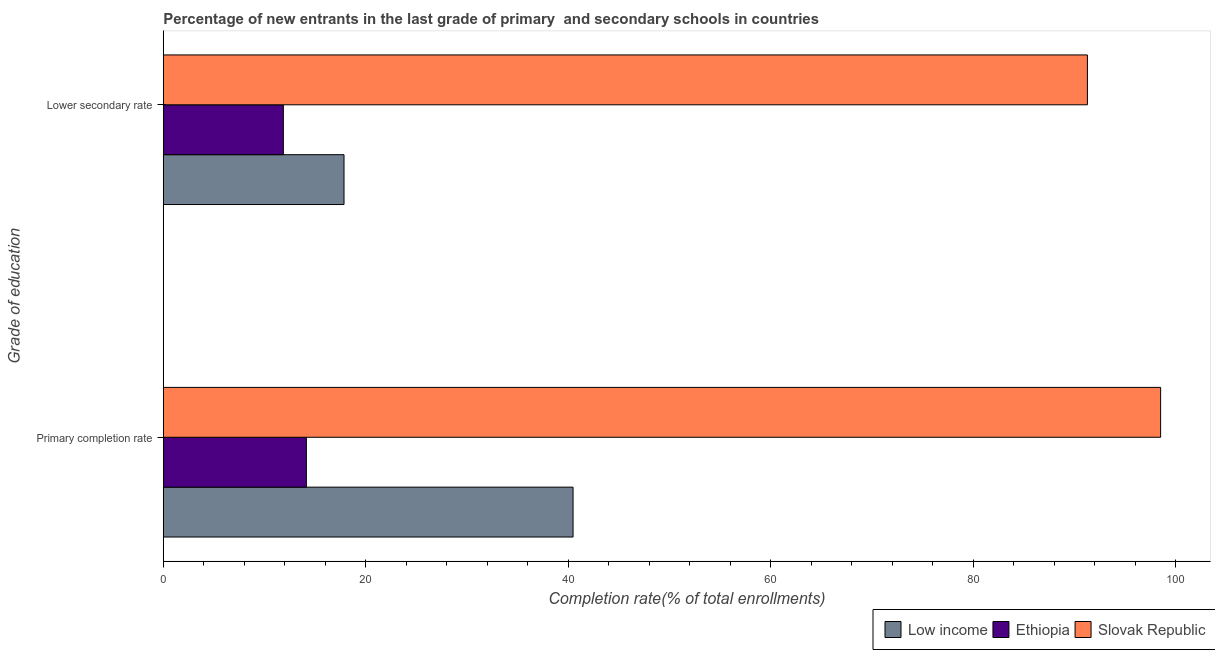How many groups of bars are there?
Make the answer very short. 2. Are the number of bars on each tick of the Y-axis equal?
Your answer should be compact. Yes. How many bars are there on the 2nd tick from the top?
Ensure brevity in your answer.  3. What is the label of the 2nd group of bars from the top?
Offer a very short reply. Primary completion rate. What is the completion rate in secondary schools in Ethiopia?
Ensure brevity in your answer.  11.86. Across all countries, what is the maximum completion rate in primary schools?
Ensure brevity in your answer.  98.52. Across all countries, what is the minimum completion rate in primary schools?
Make the answer very short. 14.14. In which country was the completion rate in secondary schools maximum?
Make the answer very short. Slovak Republic. In which country was the completion rate in primary schools minimum?
Your response must be concise. Ethiopia. What is the total completion rate in primary schools in the graph?
Make the answer very short. 153.14. What is the difference between the completion rate in primary schools in Low income and that in Slovak Republic?
Your answer should be compact. -58.04. What is the difference between the completion rate in primary schools in Slovak Republic and the completion rate in secondary schools in Ethiopia?
Your response must be concise. 86.66. What is the average completion rate in secondary schools per country?
Your answer should be very brief. 40.34. What is the difference between the completion rate in secondary schools and completion rate in primary schools in Low income?
Provide a succinct answer. -22.63. In how many countries, is the completion rate in primary schools greater than 92 %?
Your answer should be very brief. 1. What is the ratio of the completion rate in primary schools in Ethiopia to that in Slovak Republic?
Your answer should be very brief. 0.14. Is the completion rate in secondary schools in Low income less than that in Slovak Republic?
Make the answer very short. Yes. What does the 2nd bar from the top in Primary completion rate represents?
Ensure brevity in your answer.  Ethiopia. What does the 3rd bar from the bottom in Lower secondary rate represents?
Keep it short and to the point. Slovak Republic. How many bars are there?
Your response must be concise. 6. Are all the bars in the graph horizontal?
Offer a very short reply. Yes. What is the difference between two consecutive major ticks on the X-axis?
Your answer should be compact. 20. Does the graph contain any zero values?
Your answer should be compact. No. Does the graph contain grids?
Offer a very short reply. No. Where does the legend appear in the graph?
Provide a succinct answer. Bottom right. How many legend labels are there?
Ensure brevity in your answer.  3. How are the legend labels stacked?
Offer a terse response. Horizontal. What is the title of the graph?
Provide a succinct answer. Percentage of new entrants in the last grade of primary  and secondary schools in countries. Does "Togo" appear as one of the legend labels in the graph?
Ensure brevity in your answer.  No. What is the label or title of the X-axis?
Ensure brevity in your answer.  Completion rate(% of total enrollments). What is the label or title of the Y-axis?
Your answer should be compact. Grade of education. What is the Completion rate(% of total enrollments) of Low income in Primary completion rate?
Your answer should be compact. 40.48. What is the Completion rate(% of total enrollments) in Ethiopia in Primary completion rate?
Make the answer very short. 14.14. What is the Completion rate(% of total enrollments) in Slovak Republic in Primary completion rate?
Provide a short and direct response. 98.52. What is the Completion rate(% of total enrollments) of Low income in Lower secondary rate?
Your answer should be very brief. 17.86. What is the Completion rate(% of total enrollments) in Ethiopia in Lower secondary rate?
Your answer should be very brief. 11.86. What is the Completion rate(% of total enrollments) in Slovak Republic in Lower secondary rate?
Your answer should be very brief. 91.29. Across all Grade of education, what is the maximum Completion rate(% of total enrollments) of Low income?
Your response must be concise. 40.48. Across all Grade of education, what is the maximum Completion rate(% of total enrollments) of Ethiopia?
Your response must be concise. 14.14. Across all Grade of education, what is the maximum Completion rate(% of total enrollments) in Slovak Republic?
Provide a succinct answer. 98.52. Across all Grade of education, what is the minimum Completion rate(% of total enrollments) in Low income?
Your answer should be compact. 17.86. Across all Grade of education, what is the minimum Completion rate(% of total enrollments) of Ethiopia?
Keep it short and to the point. 11.86. Across all Grade of education, what is the minimum Completion rate(% of total enrollments) in Slovak Republic?
Your answer should be compact. 91.29. What is the total Completion rate(% of total enrollments) in Low income in the graph?
Provide a short and direct response. 58.34. What is the total Completion rate(% of total enrollments) in Ethiopia in the graph?
Ensure brevity in your answer.  26. What is the total Completion rate(% of total enrollments) in Slovak Republic in the graph?
Your answer should be compact. 189.82. What is the difference between the Completion rate(% of total enrollments) of Low income in Primary completion rate and that in Lower secondary rate?
Provide a short and direct response. 22.63. What is the difference between the Completion rate(% of total enrollments) of Ethiopia in Primary completion rate and that in Lower secondary rate?
Make the answer very short. 2.27. What is the difference between the Completion rate(% of total enrollments) of Slovak Republic in Primary completion rate and that in Lower secondary rate?
Your response must be concise. 7.23. What is the difference between the Completion rate(% of total enrollments) of Low income in Primary completion rate and the Completion rate(% of total enrollments) of Ethiopia in Lower secondary rate?
Provide a succinct answer. 28.62. What is the difference between the Completion rate(% of total enrollments) in Low income in Primary completion rate and the Completion rate(% of total enrollments) in Slovak Republic in Lower secondary rate?
Keep it short and to the point. -50.81. What is the difference between the Completion rate(% of total enrollments) in Ethiopia in Primary completion rate and the Completion rate(% of total enrollments) in Slovak Republic in Lower secondary rate?
Give a very brief answer. -77.15. What is the average Completion rate(% of total enrollments) in Low income per Grade of education?
Offer a terse response. 29.17. What is the average Completion rate(% of total enrollments) of Ethiopia per Grade of education?
Ensure brevity in your answer.  13. What is the average Completion rate(% of total enrollments) of Slovak Republic per Grade of education?
Your response must be concise. 94.91. What is the difference between the Completion rate(% of total enrollments) in Low income and Completion rate(% of total enrollments) in Ethiopia in Primary completion rate?
Your answer should be very brief. 26.34. What is the difference between the Completion rate(% of total enrollments) of Low income and Completion rate(% of total enrollments) of Slovak Republic in Primary completion rate?
Your response must be concise. -58.04. What is the difference between the Completion rate(% of total enrollments) in Ethiopia and Completion rate(% of total enrollments) in Slovak Republic in Primary completion rate?
Provide a succinct answer. -84.39. What is the difference between the Completion rate(% of total enrollments) of Low income and Completion rate(% of total enrollments) of Ethiopia in Lower secondary rate?
Provide a succinct answer. 5.99. What is the difference between the Completion rate(% of total enrollments) in Low income and Completion rate(% of total enrollments) in Slovak Republic in Lower secondary rate?
Your answer should be compact. -73.44. What is the difference between the Completion rate(% of total enrollments) in Ethiopia and Completion rate(% of total enrollments) in Slovak Republic in Lower secondary rate?
Your response must be concise. -79.43. What is the ratio of the Completion rate(% of total enrollments) in Low income in Primary completion rate to that in Lower secondary rate?
Provide a short and direct response. 2.27. What is the ratio of the Completion rate(% of total enrollments) of Ethiopia in Primary completion rate to that in Lower secondary rate?
Make the answer very short. 1.19. What is the ratio of the Completion rate(% of total enrollments) in Slovak Republic in Primary completion rate to that in Lower secondary rate?
Your answer should be compact. 1.08. What is the difference between the highest and the second highest Completion rate(% of total enrollments) in Low income?
Provide a succinct answer. 22.63. What is the difference between the highest and the second highest Completion rate(% of total enrollments) of Ethiopia?
Provide a succinct answer. 2.27. What is the difference between the highest and the second highest Completion rate(% of total enrollments) of Slovak Republic?
Your answer should be compact. 7.23. What is the difference between the highest and the lowest Completion rate(% of total enrollments) of Low income?
Your answer should be very brief. 22.63. What is the difference between the highest and the lowest Completion rate(% of total enrollments) in Ethiopia?
Your answer should be very brief. 2.27. What is the difference between the highest and the lowest Completion rate(% of total enrollments) of Slovak Republic?
Provide a short and direct response. 7.23. 